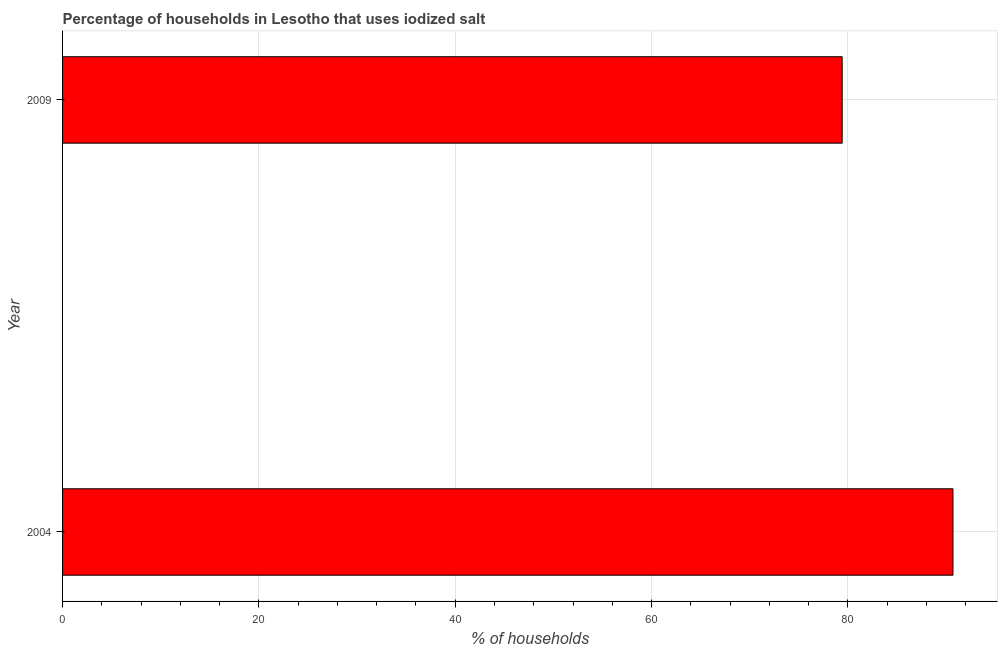Does the graph contain grids?
Your answer should be very brief. Yes. What is the title of the graph?
Your response must be concise. Percentage of households in Lesotho that uses iodized salt. What is the label or title of the X-axis?
Your response must be concise. % of households. What is the label or title of the Y-axis?
Ensure brevity in your answer.  Year. What is the percentage of households where iodized salt is consumed in 2004?
Make the answer very short. 90.7. Across all years, what is the maximum percentage of households where iodized salt is consumed?
Your answer should be compact. 90.7. Across all years, what is the minimum percentage of households where iodized salt is consumed?
Offer a terse response. 79.41. In which year was the percentage of households where iodized salt is consumed minimum?
Provide a short and direct response. 2009. What is the sum of the percentage of households where iodized salt is consumed?
Your answer should be very brief. 170.11. What is the difference between the percentage of households where iodized salt is consumed in 2004 and 2009?
Keep it short and to the point. 11.29. What is the average percentage of households where iodized salt is consumed per year?
Your answer should be compact. 85.06. What is the median percentage of households where iodized salt is consumed?
Give a very brief answer. 85.06. In how many years, is the percentage of households where iodized salt is consumed greater than 12 %?
Provide a short and direct response. 2. What is the ratio of the percentage of households where iodized salt is consumed in 2004 to that in 2009?
Ensure brevity in your answer.  1.14. Is the percentage of households where iodized salt is consumed in 2004 less than that in 2009?
Offer a very short reply. No. In how many years, is the percentage of households where iodized salt is consumed greater than the average percentage of households where iodized salt is consumed taken over all years?
Your answer should be very brief. 1. Are the values on the major ticks of X-axis written in scientific E-notation?
Offer a terse response. No. What is the % of households of 2004?
Your answer should be very brief. 90.7. What is the % of households in 2009?
Offer a terse response. 79.41. What is the difference between the % of households in 2004 and 2009?
Offer a terse response. 11.29. What is the ratio of the % of households in 2004 to that in 2009?
Keep it short and to the point. 1.14. 